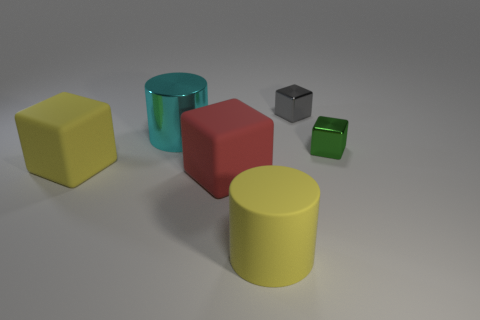Are there the same number of large yellow rubber things that are to the right of the big red cube and cyan things?
Offer a terse response. Yes. The large metal cylinder has what color?
Keep it short and to the point. Cyan. There is a green object that is made of the same material as the gray thing; what is its size?
Your answer should be compact. Small. The other small block that is the same material as the green block is what color?
Offer a terse response. Gray. Is there a gray shiny thing of the same size as the green metallic block?
Offer a very short reply. Yes. What is the material of the gray thing that is the same shape as the green thing?
Give a very brief answer. Metal. There is a cyan thing that is the same size as the yellow rubber cylinder; what shape is it?
Provide a succinct answer. Cylinder. Is there another big cyan thing of the same shape as the cyan shiny thing?
Your answer should be very brief. No. The large thing that is behind the small thing that is to the right of the gray shiny thing is what shape?
Your answer should be very brief. Cylinder. There is a tiny green shiny thing; what shape is it?
Offer a terse response. Cube. 